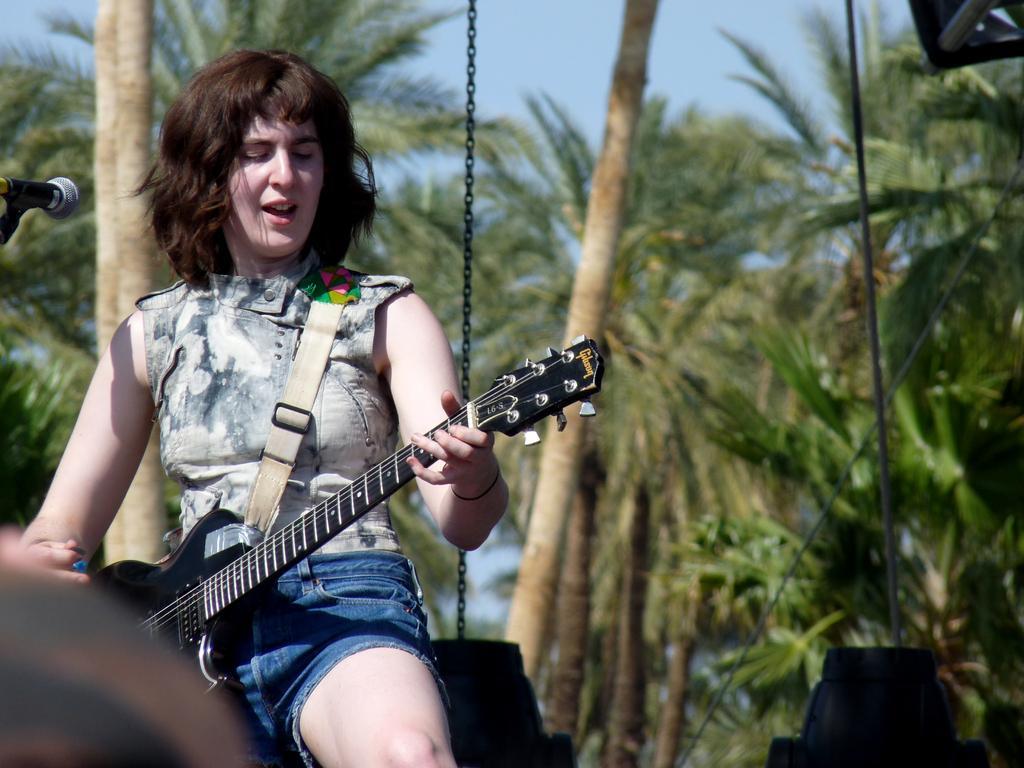Please provide a concise description of this image. In this image, there is a person sitting in a swing and playing a guitar. There is a mic in front of this person. There are some trees and sky behind this person. This person wearing colorful clothes. 